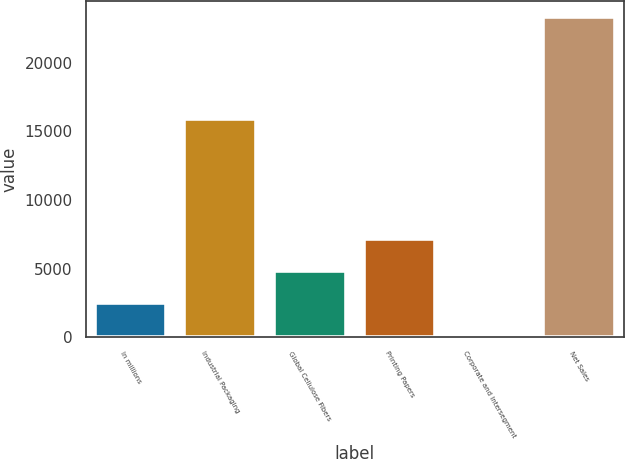<chart> <loc_0><loc_0><loc_500><loc_500><bar_chart><fcel>In millions<fcel>Industrial Packaging<fcel>Global Cellulose Fibers<fcel>Printing Papers<fcel>Corporate and Intersegment<fcel>Net Sales<nl><fcel>2521.4<fcel>15900<fcel>4830.8<fcel>7140.2<fcel>212<fcel>23306<nl></chart> 